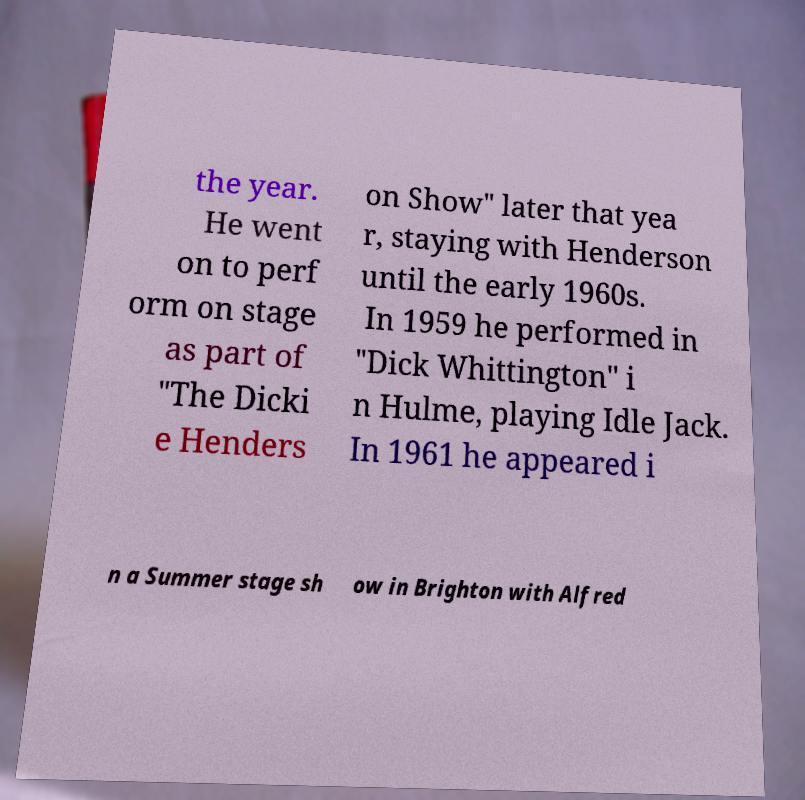Please identify and transcribe the text found in this image. the year. He went on to perf orm on stage as part of "The Dicki e Henders on Show" later that yea r, staying with Henderson until the early 1960s. In 1959 he performed in "Dick Whittington" i n Hulme, playing Idle Jack. In 1961 he appeared i n a Summer stage sh ow in Brighton with Alfred 